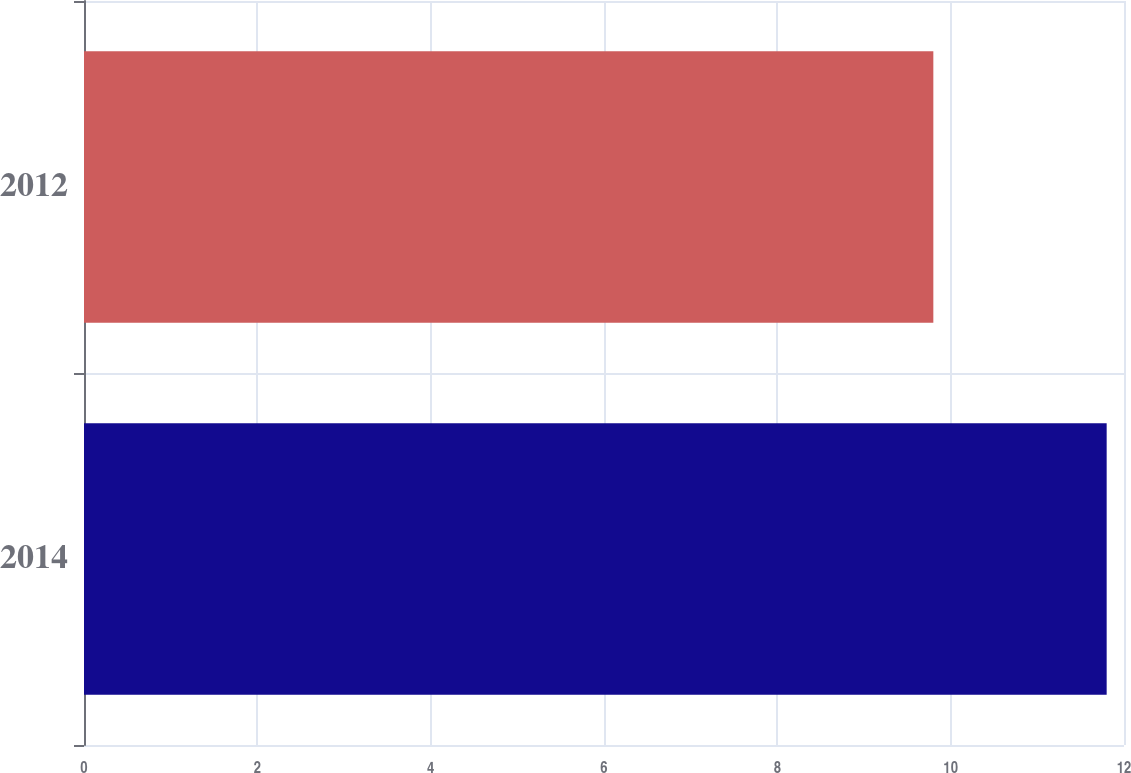Convert chart. <chart><loc_0><loc_0><loc_500><loc_500><bar_chart><fcel>2014<fcel>2012<nl><fcel>11.8<fcel>9.8<nl></chart> 